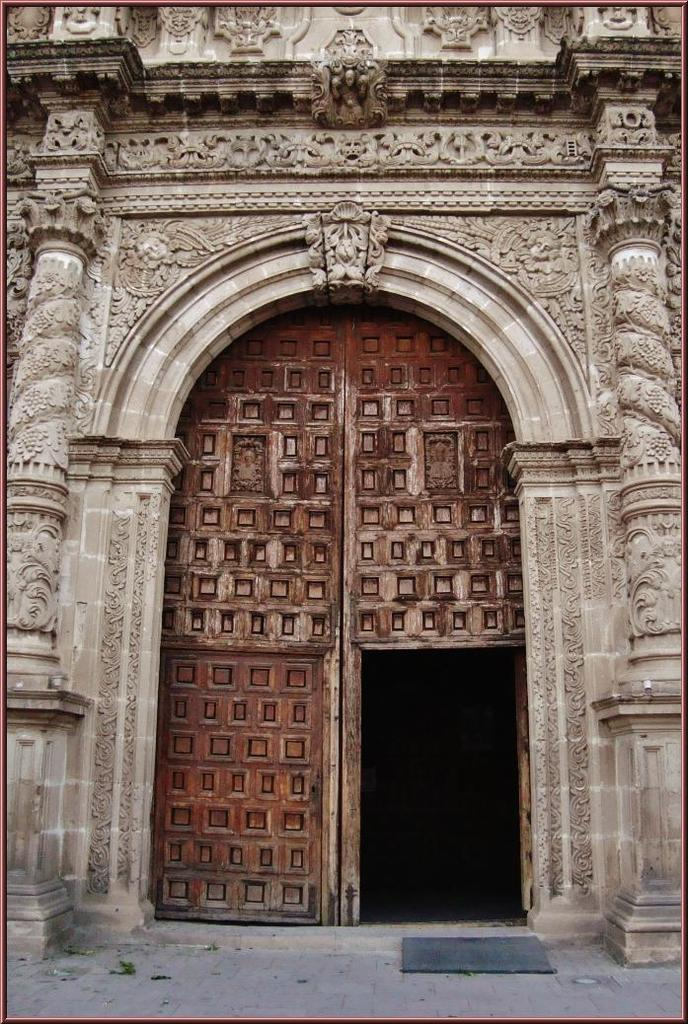What type of structure is visible in the image? There is a wall in the image. What feature can be seen on the wall? The wall has pillars. Is there any entrance visible in the image? Yes, there is a door in the image. What type of hobbies do the pillars on the wall enjoy? Pillars do not have hobbies, as they are inanimate objects. 